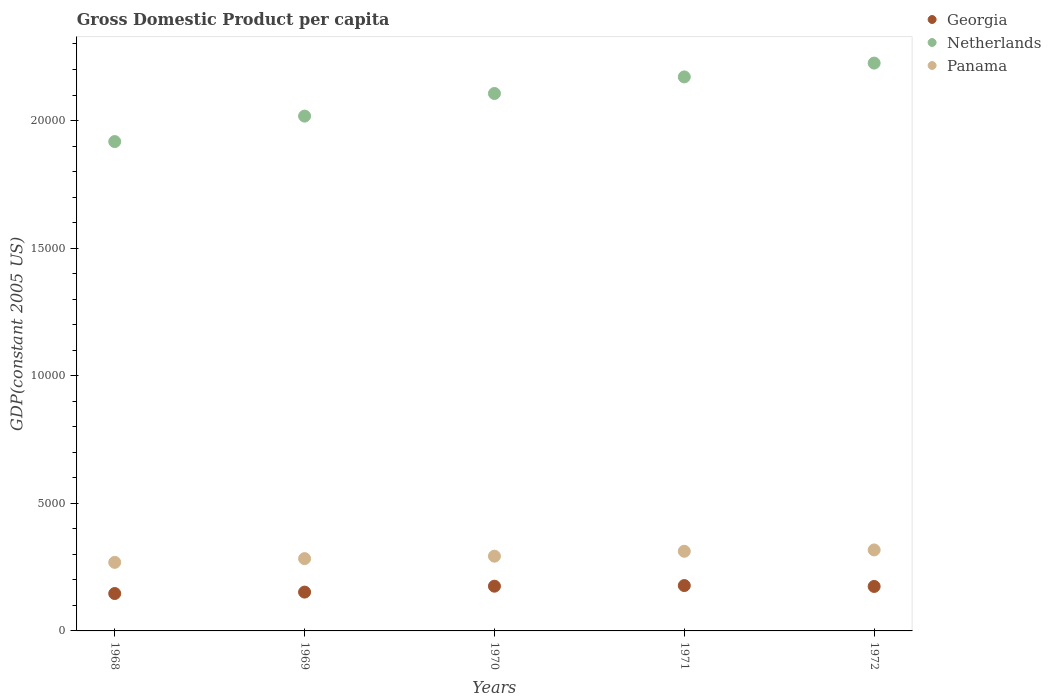How many different coloured dotlines are there?
Provide a succinct answer. 3. Is the number of dotlines equal to the number of legend labels?
Your response must be concise. Yes. What is the GDP per capita in Panama in 1969?
Offer a terse response. 2832.95. Across all years, what is the maximum GDP per capita in Georgia?
Make the answer very short. 1777.67. Across all years, what is the minimum GDP per capita in Netherlands?
Ensure brevity in your answer.  1.92e+04. In which year was the GDP per capita in Netherlands maximum?
Make the answer very short. 1972. In which year was the GDP per capita in Netherlands minimum?
Your answer should be very brief. 1968. What is the total GDP per capita in Netherlands in the graph?
Provide a succinct answer. 1.04e+05. What is the difference between the GDP per capita in Georgia in 1968 and that in 1970?
Make the answer very short. -287.41. What is the difference between the GDP per capita in Netherlands in 1971 and the GDP per capita in Panama in 1972?
Provide a succinct answer. 1.85e+04. What is the average GDP per capita in Netherlands per year?
Offer a very short reply. 2.09e+04. In the year 1972, what is the difference between the GDP per capita in Georgia and GDP per capita in Panama?
Offer a terse response. -1430.68. In how many years, is the GDP per capita in Georgia greater than 2000 US$?
Your answer should be compact. 0. What is the ratio of the GDP per capita in Netherlands in 1968 to that in 1970?
Ensure brevity in your answer.  0.91. What is the difference between the highest and the second highest GDP per capita in Netherlands?
Your answer should be compact. 541.08. What is the difference between the highest and the lowest GDP per capita in Georgia?
Your answer should be compact. 312.09. In how many years, is the GDP per capita in Georgia greater than the average GDP per capita in Georgia taken over all years?
Provide a short and direct response. 3. Does the GDP per capita in Georgia monotonically increase over the years?
Your answer should be compact. No. Is the GDP per capita in Netherlands strictly greater than the GDP per capita in Panama over the years?
Make the answer very short. Yes. Is the GDP per capita in Netherlands strictly less than the GDP per capita in Georgia over the years?
Your answer should be compact. No. How many years are there in the graph?
Offer a terse response. 5. Does the graph contain grids?
Offer a very short reply. No. How many legend labels are there?
Give a very brief answer. 3. How are the legend labels stacked?
Your answer should be very brief. Vertical. What is the title of the graph?
Offer a very short reply. Gross Domestic Product per capita. Does "Heavily indebted poor countries" appear as one of the legend labels in the graph?
Your answer should be compact. No. What is the label or title of the X-axis?
Provide a succinct answer. Years. What is the label or title of the Y-axis?
Give a very brief answer. GDP(constant 2005 US). What is the GDP(constant 2005 US) in Georgia in 1968?
Offer a terse response. 1465.58. What is the GDP(constant 2005 US) of Netherlands in 1968?
Make the answer very short. 1.92e+04. What is the GDP(constant 2005 US) of Panama in 1968?
Make the answer very short. 2686.42. What is the GDP(constant 2005 US) of Georgia in 1969?
Give a very brief answer. 1521.31. What is the GDP(constant 2005 US) in Netherlands in 1969?
Provide a succinct answer. 2.02e+04. What is the GDP(constant 2005 US) in Panama in 1969?
Provide a short and direct response. 2832.95. What is the GDP(constant 2005 US) in Georgia in 1970?
Provide a succinct answer. 1752.99. What is the GDP(constant 2005 US) of Netherlands in 1970?
Offer a terse response. 2.11e+04. What is the GDP(constant 2005 US) in Panama in 1970?
Keep it short and to the point. 2928.95. What is the GDP(constant 2005 US) of Georgia in 1971?
Give a very brief answer. 1777.67. What is the GDP(constant 2005 US) of Netherlands in 1971?
Provide a succinct answer. 2.17e+04. What is the GDP(constant 2005 US) in Panama in 1971?
Your answer should be compact. 3121.45. What is the GDP(constant 2005 US) in Georgia in 1972?
Ensure brevity in your answer.  1742.94. What is the GDP(constant 2005 US) in Netherlands in 1972?
Provide a short and direct response. 2.23e+04. What is the GDP(constant 2005 US) in Panama in 1972?
Give a very brief answer. 3173.62. Across all years, what is the maximum GDP(constant 2005 US) in Georgia?
Offer a terse response. 1777.67. Across all years, what is the maximum GDP(constant 2005 US) of Netherlands?
Offer a very short reply. 2.23e+04. Across all years, what is the maximum GDP(constant 2005 US) in Panama?
Provide a succinct answer. 3173.62. Across all years, what is the minimum GDP(constant 2005 US) in Georgia?
Your response must be concise. 1465.58. Across all years, what is the minimum GDP(constant 2005 US) in Netherlands?
Your answer should be compact. 1.92e+04. Across all years, what is the minimum GDP(constant 2005 US) in Panama?
Your response must be concise. 2686.42. What is the total GDP(constant 2005 US) of Georgia in the graph?
Keep it short and to the point. 8260.48. What is the total GDP(constant 2005 US) in Netherlands in the graph?
Ensure brevity in your answer.  1.04e+05. What is the total GDP(constant 2005 US) in Panama in the graph?
Offer a terse response. 1.47e+04. What is the difference between the GDP(constant 2005 US) in Georgia in 1968 and that in 1969?
Make the answer very short. -55.73. What is the difference between the GDP(constant 2005 US) of Netherlands in 1968 and that in 1969?
Ensure brevity in your answer.  -997.98. What is the difference between the GDP(constant 2005 US) in Panama in 1968 and that in 1969?
Provide a short and direct response. -146.53. What is the difference between the GDP(constant 2005 US) of Georgia in 1968 and that in 1970?
Your answer should be compact. -287.41. What is the difference between the GDP(constant 2005 US) of Netherlands in 1968 and that in 1970?
Provide a short and direct response. -1884.33. What is the difference between the GDP(constant 2005 US) of Panama in 1968 and that in 1970?
Offer a terse response. -242.53. What is the difference between the GDP(constant 2005 US) in Georgia in 1968 and that in 1971?
Your answer should be compact. -312.09. What is the difference between the GDP(constant 2005 US) in Netherlands in 1968 and that in 1971?
Your answer should be compact. -2533.82. What is the difference between the GDP(constant 2005 US) of Panama in 1968 and that in 1971?
Keep it short and to the point. -435.03. What is the difference between the GDP(constant 2005 US) in Georgia in 1968 and that in 1972?
Ensure brevity in your answer.  -277.36. What is the difference between the GDP(constant 2005 US) in Netherlands in 1968 and that in 1972?
Make the answer very short. -3074.9. What is the difference between the GDP(constant 2005 US) in Panama in 1968 and that in 1972?
Provide a short and direct response. -487.2. What is the difference between the GDP(constant 2005 US) of Georgia in 1969 and that in 1970?
Keep it short and to the point. -231.68. What is the difference between the GDP(constant 2005 US) in Netherlands in 1969 and that in 1970?
Keep it short and to the point. -886.35. What is the difference between the GDP(constant 2005 US) of Panama in 1969 and that in 1970?
Your response must be concise. -96. What is the difference between the GDP(constant 2005 US) of Georgia in 1969 and that in 1971?
Your answer should be compact. -256.36. What is the difference between the GDP(constant 2005 US) in Netherlands in 1969 and that in 1971?
Provide a succinct answer. -1535.84. What is the difference between the GDP(constant 2005 US) of Panama in 1969 and that in 1971?
Ensure brevity in your answer.  -288.49. What is the difference between the GDP(constant 2005 US) of Georgia in 1969 and that in 1972?
Ensure brevity in your answer.  -221.63. What is the difference between the GDP(constant 2005 US) of Netherlands in 1969 and that in 1972?
Your answer should be very brief. -2076.92. What is the difference between the GDP(constant 2005 US) of Panama in 1969 and that in 1972?
Provide a short and direct response. -340.66. What is the difference between the GDP(constant 2005 US) of Georgia in 1970 and that in 1971?
Provide a succinct answer. -24.68. What is the difference between the GDP(constant 2005 US) in Netherlands in 1970 and that in 1971?
Provide a short and direct response. -649.49. What is the difference between the GDP(constant 2005 US) in Panama in 1970 and that in 1971?
Your answer should be compact. -192.49. What is the difference between the GDP(constant 2005 US) in Georgia in 1970 and that in 1972?
Your answer should be compact. 10.05. What is the difference between the GDP(constant 2005 US) of Netherlands in 1970 and that in 1972?
Provide a succinct answer. -1190.57. What is the difference between the GDP(constant 2005 US) in Panama in 1970 and that in 1972?
Your response must be concise. -244.66. What is the difference between the GDP(constant 2005 US) of Georgia in 1971 and that in 1972?
Your answer should be compact. 34.73. What is the difference between the GDP(constant 2005 US) of Netherlands in 1971 and that in 1972?
Your answer should be compact. -541.08. What is the difference between the GDP(constant 2005 US) in Panama in 1971 and that in 1972?
Offer a terse response. -52.17. What is the difference between the GDP(constant 2005 US) in Georgia in 1968 and the GDP(constant 2005 US) in Netherlands in 1969?
Provide a short and direct response. -1.87e+04. What is the difference between the GDP(constant 2005 US) of Georgia in 1968 and the GDP(constant 2005 US) of Panama in 1969?
Provide a succinct answer. -1367.37. What is the difference between the GDP(constant 2005 US) in Netherlands in 1968 and the GDP(constant 2005 US) in Panama in 1969?
Your answer should be compact. 1.63e+04. What is the difference between the GDP(constant 2005 US) in Georgia in 1968 and the GDP(constant 2005 US) in Netherlands in 1970?
Offer a very short reply. -1.96e+04. What is the difference between the GDP(constant 2005 US) of Georgia in 1968 and the GDP(constant 2005 US) of Panama in 1970?
Your response must be concise. -1463.37. What is the difference between the GDP(constant 2005 US) of Netherlands in 1968 and the GDP(constant 2005 US) of Panama in 1970?
Your answer should be compact. 1.62e+04. What is the difference between the GDP(constant 2005 US) of Georgia in 1968 and the GDP(constant 2005 US) of Netherlands in 1971?
Your answer should be compact. -2.02e+04. What is the difference between the GDP(constant 2005 US) in Georgia in 1968 and the GDP(constant 2005 US) in Panama in 1971?
Give a very brief answer. -1655.87. What is the difference between the GDP(constant 2005 US) in Netherlands in 1968 and the GDP(constant 2005 US) in Panama in 1971?
Your answer should be very brief. 1.61e+04. What is the difference between the GDP(constant 2005 US) of Georgia in 1968 and the GDP(constant 2005 US) of Netherlands in 1972?
Provide a succinct answer. -2.08e+04. What is the difference between the GDP(constant 2005 US) of Georgia in 1968 and the GDP(constant 2005 US) of Panama in 1972?
Offer a terse response. -1708.04. What is the difference between the GDP(constant 2005 US) of Netherlands in 1968 and the GDP(constant 2005 US) of Panama in 1972?
Keep it short and to the point. 1.60e+04. What is the difference between the GDP(constant 2005 US) of Georgia in 1969 and the GDP(constant 2005 US) of Netherlands in 1970?
Ensure brevity in your answer.  -1.95e+04. What is the difference between the GDP(constant 2005 US) in Georgia in 1969 and the GDP(constant 2005 US) in Panama in 1970?
Provide a short and direct response. -1407.65. What is the difference between the GDP(constant 2005 US) in Netherlands in 1969 and the GDP(constant 2005 US) in Panama in 1970?
Your answer should be very brief. 1.72e+04. What is the difference between the GDP(constant 2005 US) in Georgia in 1969 and the GDP(constant 2005 US) in Netherlands in 1971?
Your answer should be compact. -2.02e+04. What is the difference between the GDP(constant 2005 US) in Georgia in 1969 and the GDP(constant 2005 US) in Panama in 1971?
Provide a succinct answer. -1600.14. What is the difference between the GDP(constant 2005 US) in Netherlands in 1969 and the GDP(constant 2005 US) in Panama in 1971?
Ensure brevity in your answer.  1.71e+04. What is the difference between the GDP(constant 2005 US) in Georgia in 1969 and the GDP(constant 2005 US) in Netherlands in 1972?
Your answer should be compact. -2.07e+04. What is the difference between the GDP(constant 2005 US) in Georgia in 1969 and the GDP(constant 2005 US) in Panama in 1972?
Keep it short and to the point. -1652.31. What is the difference between the GDP(constant 2005 US) of Netherlands in 1969 and the GDP(constant 2005 US) of Panama in 1972?
Make the answer very short. 1.70e+04. What is the difference between the GDP(constant 2005 US) of Georgia in 1970 and the GDP(constant 2005 US) of Netherlands in 1971?
Provide a short and direct response. -2.00e+04. What is the difference between the GDP(constant 2005 US) in Georgia in 1970 and the GDP(constant 2005 US) in Panama in 1971?
Your response must be concise. -1368.46. What is the difference between the GDP(constant 2005 US) of Netherlands in 1970 and the GDP(constant 2005 US) of Panama in 1971?
Provide a succinct answer. 1.79e+04. What is the difference between the GDP(constant 2005 US) of Georgia in 1970 and the GDP(constant 2005 US) of Netherlands in 1972?
Provide a succinct answer. -2.05e+04. What is the difference between the GDP(constant 2005 US) in Georgia in 1970 and the GDP(constant 2005 US) in Panama in 1972?
Offer a terse response. -1420.63. What is the difference between the GDP(constant 2005 US) in Netherlands in 1970 and the GDP(constant 2005 US) in Panama in 1972?
Provide a succinct answer. 1.79e+04. What is the difference between the GDP(constant 2005 US) of Georgia in 1971 and the GDP(constant 2005 US) of Netherlands in 1972?
Give a very brief answer. -2.05e+04. What is the difference between the GDP(constant 2005 US) of Georgia in 1971 and the GDP(constant 2005 US) of Panama in 1972?
Provide a succinct answer. -1395.95. What is the difference between the GDP(constant 2005 US) in Netherlands in 1971 and the GDP(constant 2005 US) in Panama in 1972?
Your answer should be compact. 1.85e+04. What is the average GDP(constant 2005 US) in Georgia per year?
Make the answer very short. 1652.1. What is the average GDP(constant 2005 US) of Netherlands per year?
Offer a very short reply. 2.09e+04. What is the average GDP(constant 2005 US) of Panama per year?
Provide a succinct answer. 2948.68. In the year 1968, what is the difference between the GDP(constant 2005 US) of Georgia and GDP(constant 2005 US) of Netherlands?
Your answer should be very brief. -1.77e+04. In the year 1968, what is the difference between the GDP(constant 2005 US) of Georgia and GDP(constant 2005 US) of Panama?
Provide a short and direct response. -1220.84. In the year 1968, what is the difference between the GDP(constant 2005 US) of Netherlands and GDP(constant 2005 US) of Panama?
Provide a succinct answer. 1.65e+04. In the year 1969, what is the difference between the GDP(constant 2005 US) of Georgia and GDP(constant 2005 US) of Netherlands?
Provide a short and direct response. -1.87e+04. In the year 1969, what is the difference between the GDP(constant 2005 US) in Georgia and GDP(constant 2005 US) in Panama?
Ensure brevity in your answer.  -1311.65. In the year 1969, what is the difference between the GDP(constant 2005 US) of Netherlands and GDP(constant 2005 US) of Panama?
Your response must be concise. 1.73e+04. In the year 1970, what is the difference between the GDP(constant 2005 US) of Georgia and GDP(constant 2005 US) of Netherlands?
Your response must be concise. -1.93e+04. In the year 1970, what is the difference between the GDP(constant 2005 US) of Georgia and GDP(constant 2005 US) of Panama?
Make the answer very short. -1175.96. In the year 1970, what is the difference between the GDP(constant 2005 US) of Netherlands and GDP(constant 2005 US) of Panama?
Keep it short and to the point. 1.81e+04. In the year 1971, what is the difference between the GDP(constant 2005 US) in Georgia and GDP(constant 2005 US) in Netherlands?
Make the answer very short. -1.99e+04. In the year 1971, what is the difference between the GDP(constant 2005 US) in Georgia and GDP(constant 2005 US) in Panama?
Make the answer very short. -1343.78. In the year 1971, what is the difference between the GDP(constant 2005 US) of Netherlands and GDP(constant 2005 US) of Panama?
Provide a short and direct response. 1.86e+04. In the year 1972, what is the difference between the GDP(constant 2005 US) of Georgia and GDP(constant 2005 US) of Netherlands?
Give a very brief answer. -2.05e+04. In the year 1972, what is the difference between the GDP(constant 2005 US) of Georgia and GDP(constant 2005 US) of Panama?
Give a very brief answer. -1430.68. In the year 1972, what is the difference between the GDP(constant 2005 US) in Netherlands and GDP(constant 2005 US) in Panama?
Provide a succinct answer. 1.91e+04. What is the ratio of the GDP(constant 2005 US) of Georgia in 1968 to that in 1969?
Offer a terse response. 0.96. What is the ratio of the GDP(constant 2005 US) in Netherlands in 1968 to that in 1969?
Your answer should be compact. 0.95. What is the ratio of the GDP(constant 2005 US) in Panama in 1968 to that in 1969?
Provide a short and direct response. 0.95. What is the ratio of the GDP(constant 2005 US) of Georgia in 1968 to that in 1970?
Offer a terse response. 0.84. What is the ratio of the GDP(constant 2005 US) of Netherlands in 1968 to that in 1970?
Make the answer very short. 0.91. What is the ratio of the GDP(constant 2005 US) of Panama in 1968 to that in 1970?
Ensure brevity in your answer.  0.92. What is the ratio of the GDP(constant 2005 US) of Georgia in 1968 to that in 1971?
Provide a short and direct response. 0.82. What is the ratio of the GDP(constant 2005 US) in Netherlands in 1968 to that in 1971?
Give a very brief answer. 0.88. What is the ratio of the GDP(constant 2005 US) in Panama in 1968 to that in 1971?
Give a very brief answer. 0.86. What is the ratio of the GDP(constant 2005 US) of Georgia in 1968 to that in 1972?
Your answer should be compact. 0.84. What is the ratio of the GDP(constant 2005 US) of Netherlands in 1968 to that in 1972?
Make the answer very short. 0.86. What is the ratio of the GDP(constant 2005 US) of Panama in 1968 to that in 1972?
Provide a succinct answer. 0.85. What is the ratio of the GDP(constant 2005 US) of Georgia in 1969 to that in 1970?
Give a very brief answer. 0.87. What is the ratio of the GDP(constant 2005 US) in Netherlands in 1969 to that in 1970?
Keep it short and to the point. 0.96. What is the ratio of the GDP(constant 2005 US) of Panama in 1969 to that in 1970?
Make the answer very short. 0.97. What is the ratio of the GDP(constant 2005 US) of Georgia in 1969 to that in 1971?
Offer a very short reply. 0.86. What is the ratio of the GDP(constant 2005 US) in Netherlands in 1969 to that in 1971?
Keep it short and to the point. 0.93. What is the ratio of the GDP(constant 2005 US) of Panama in 1969 to that in 1971?
Your answer should be compact. 0.91. What is the ratio of the GDP(constant 2005 US) in Georgia in 1969 to that in 1972?
Offer a terse response. 0.87. What is the ratio of the GDP(constant 2005 US) of Netherlands in 1969 to that in 1972?
Ensure brevity in your answer.  0.91. What is the ratio of the GDP(constant 2005 US) in Panama in 1969 to that in 1972?
Your answer should be very brief. 0.89. What is the ratio of the GDP(constant 2005 US) of Georgia in 1970 to that in 1971?
Keep it short and to the point. 0.99. What is the ratio of the GDP(constant 2005 US) in Netherlands in 1970 to that in 1971?
Offer a terse response. 0.97. What is the ratio of the GDP(constant 2005 US) of Panama in 1970 to that in 1971?
Keep it short and to the point. 0.94. What is the ratio of the GDP(constant 2005 US) of Georgia in 1970 to that in 1972?
Give a very brief answer. 1.01. What is the ratio of the GDP(constant 2005 US) in Netherlands in 1970 to that in 1972?
Provide a short and direct response. 0.95. What is the ratio of the GDP(constant 2005 US) of Panama in 1970 to that in 1972?
Your answer should be compact. 0.92. What is the ratio of the GDP(constant 2005 US) of Georgia in 1971 to that in 1972?
Make the answer very short. 1.02. What is the ratio of the GDP(constant 2005 US) of Netherlands in 1971 to that in 1972?
Your response must be concise. 0.98. What is the ratio of the GDP(constant 2005 US) in Panama in 1971 to that in 1972?
Your response must be concise. 0.98. What is the difference between the highest and the second highest GDP(constant 2005 US) of Georgia?
Provide a succinct answer. 24.68. What is the difference between the highest and the second highest GDP(constant 2005 US) of Netherlands?
Offer a terse response. 541.08. What is the difference between the highest and the second highest GDP(constant 2005 US) of Panama?
Provide a short and direct response. 52.17. What is the difference between the highest and the lowest GDP(constant 2005 US) of Georgia?
Provide a succinct answer. 312.09. What is the difference between the highest and the lowest GDP(constant 2005 US) of Netherlands?
Give a very brief answer. 3074.9. What is the difference between the highest and the lowest GDP(constant 2005 US) of Panama?
Give a very brief answer. 487.2. 